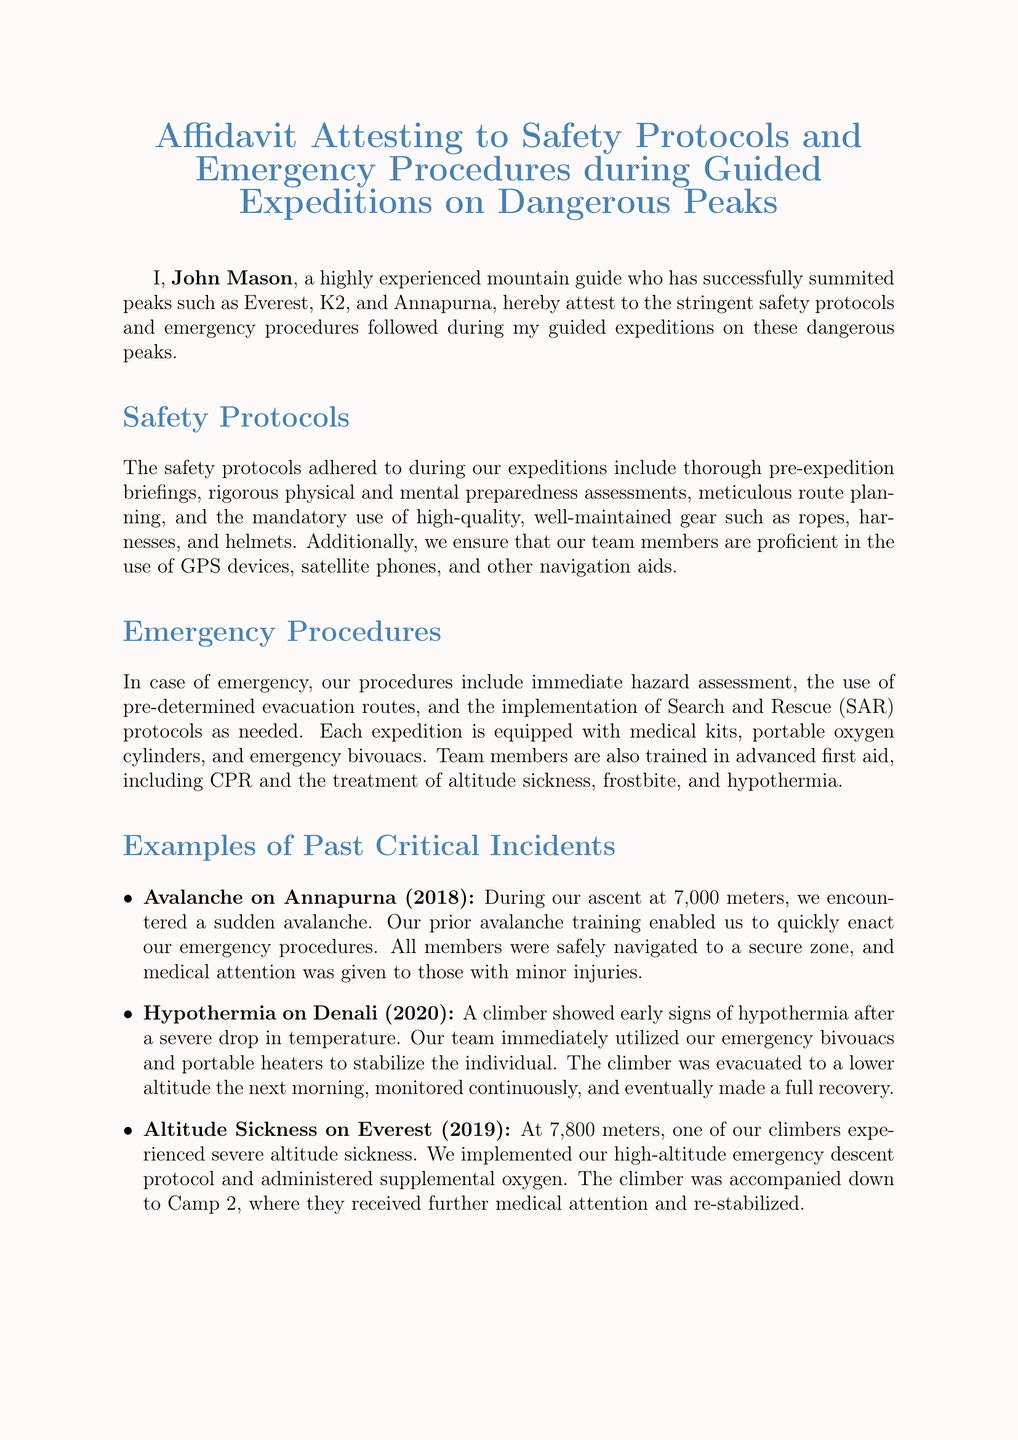What is the name of the affiant? The name of the affiant is stated at the beginning of the document.
Answer: John Mason What peaks has John Mason successfully summited? The document lists the peaks conquered by John Mason.
Answer: Everest, K2, Annapurna What is included in the emergency procedures? The document mentions the key elements involved in emergency procedures.
Answer: Immediate hazard assessment, evacuation routes, SAR protocols When did the avalanche incident occur? The date of the avalanche incident is specified in the examples provided.
Answer: 2018 What team member training is emphasized for emergencies? The document indicates the type of training that team members undergo for emergencies.
Answer: Advanced first aid What altitude was the climber experiencing altitude sickness? The document provides a specific altitude related to the altitude sickness incident.
Answer: 7,800 meters What type of emergency equipment is mentioned? The document lists the types of emergency equipment included in expeditions.
Answer: Medical kits, portable oxygen cylinders, emergency bivouacs What event prompted the use of emergency bivouacs? The document specifies a critical situation where emergency bivouacs were utilized.
Answer: Severe hypothermia What is the primary focus of the expeditions led by John Mason? The document emphasizes the key priority in conducting expeditions.
Answer: Safety and preparedness 